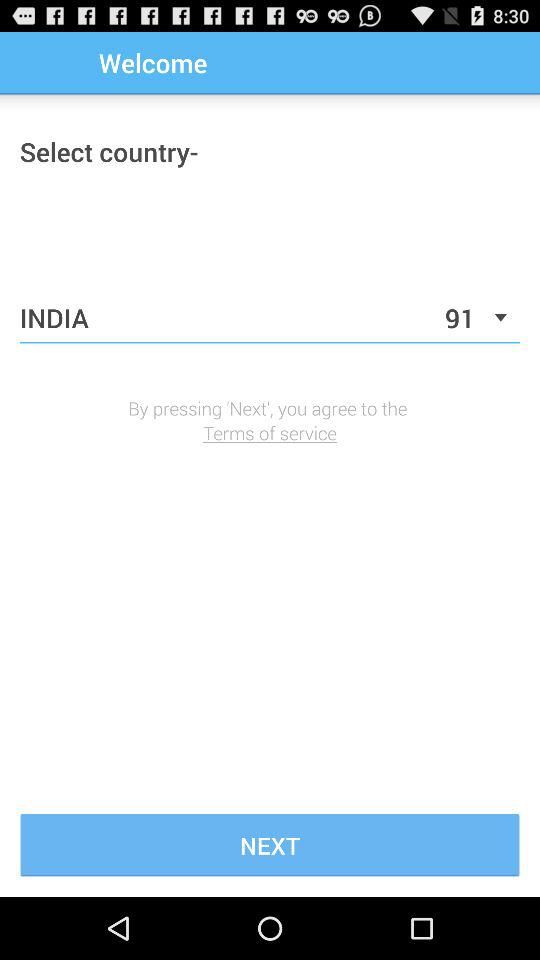What country has been selected? The selected country is "INDIA". 